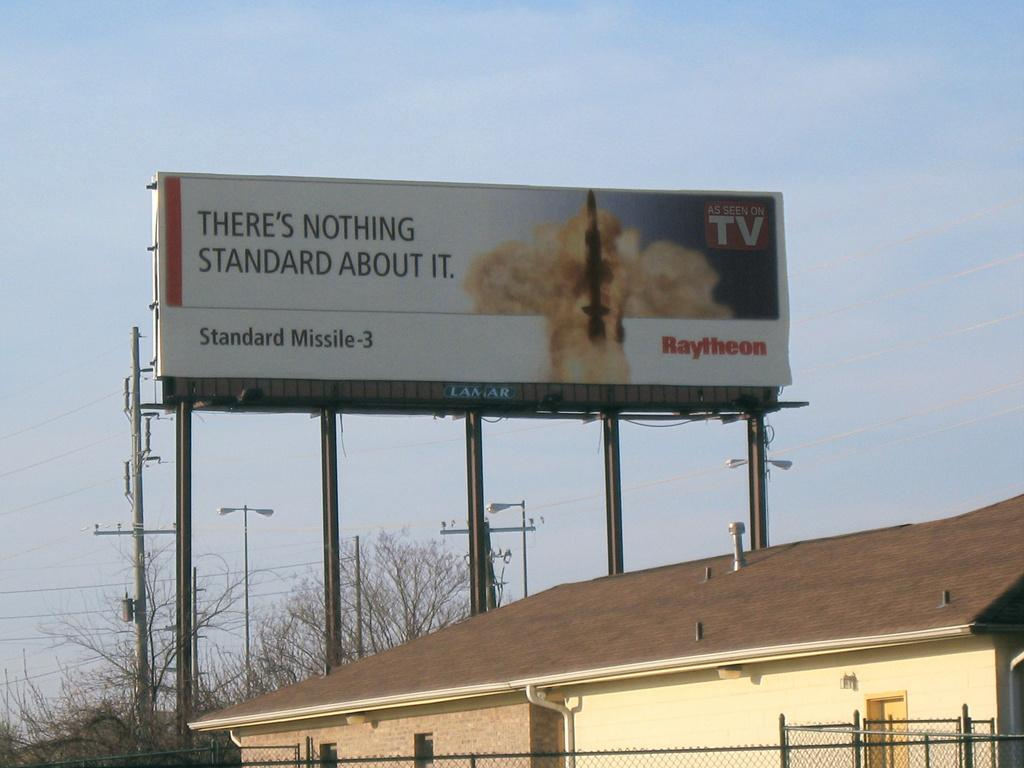<image>
Write a terse but informative summary of the picture. A rocket missile is being launched on a billboard image for Raytheon. 